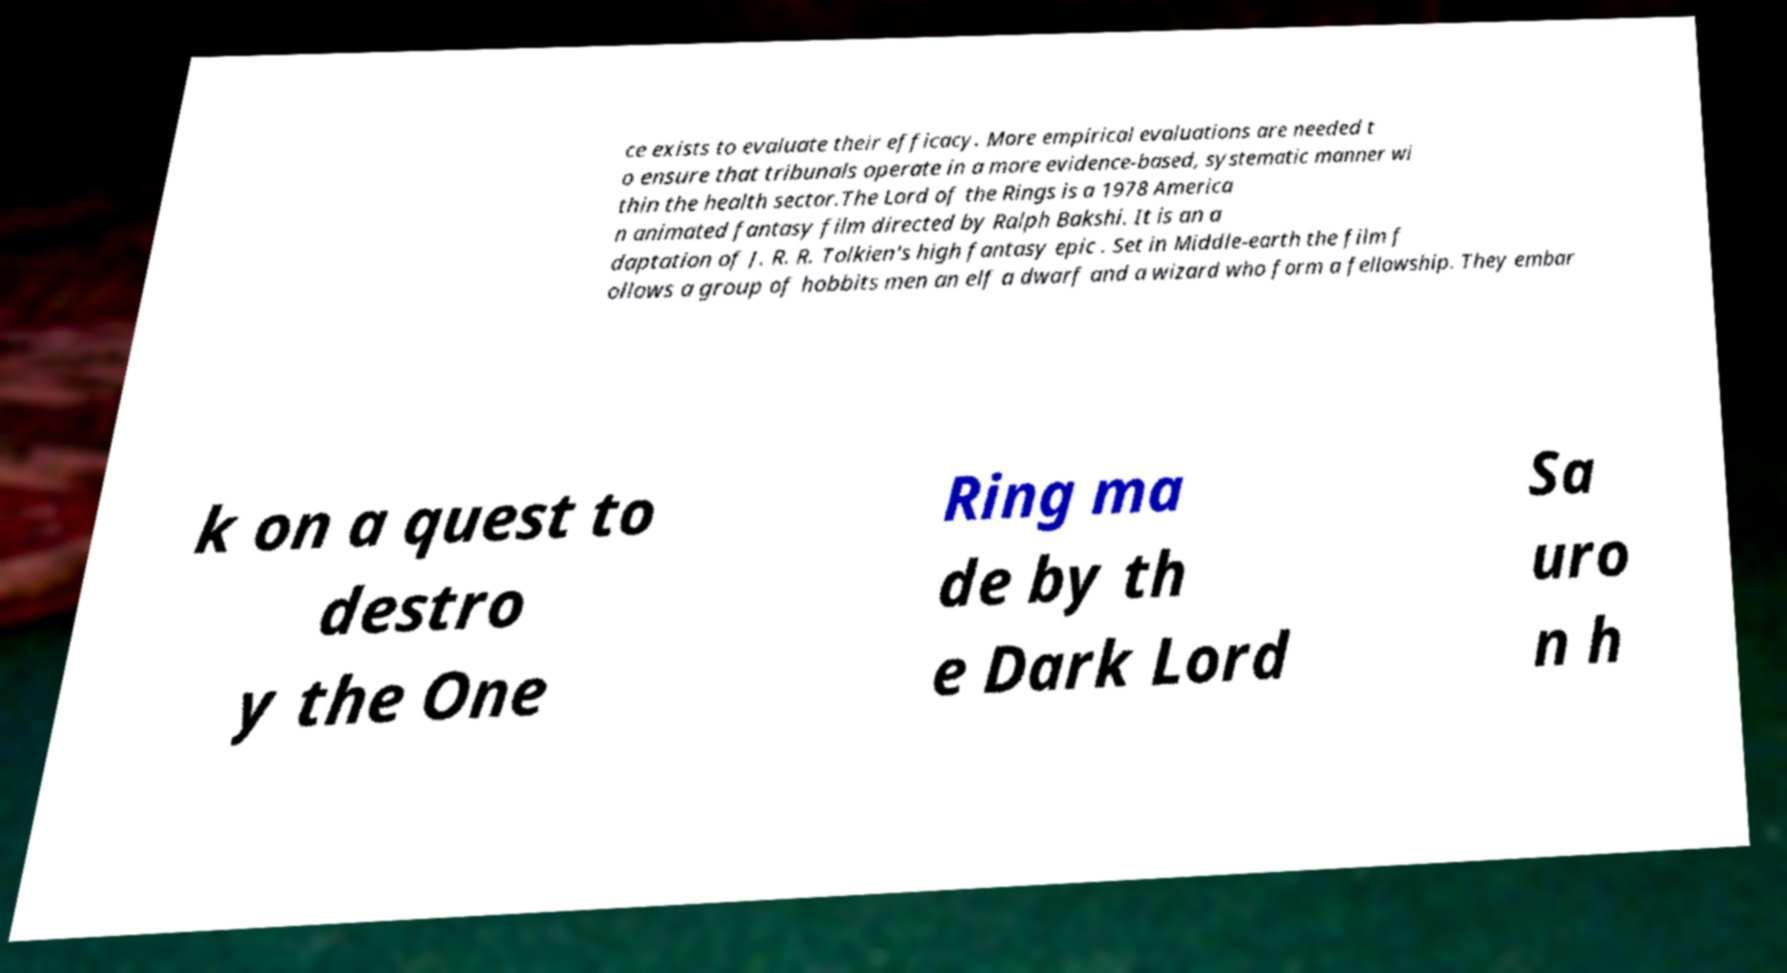Please read and relay the text visible in this image. What does it say? ce exists to evaluate their efficacy. More empirical evaluations are needed t o ensure that tribunals operate in a more evidence-based, systematic manner wi thin the health sector.The Lord of the Rings is a 1978 America n animated fantasy film directed by Ralph Bakshi. It is an a daptation of J. R. R. Tolkien's high fantasy epic . Set in Middle-earth the film f ollows a group of hobbits men an elf a dwarf and a wizard who form a fellowship. They embar k on a quest to destro y the One Ring ma de by th e Dark Lord Sa uro n h 